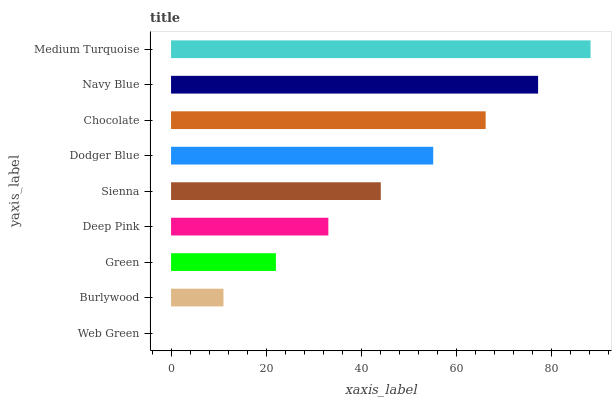Is Web Green the minimum?
Answer yes or no. Yes. Is Medium Turquoise the maximum?
Answer yes or no. Yes. Is Burlywood the minimum?
Answer yes or no. No. Is Burlywood the maximum?
Answer yes or no. No. Is Burlywood greater than Web Green?
Answer yes or no. Yes. Is Web Green less than Burlywood?
Answer yes or no. Yes. Is Web Green greater than Burlywood?
Answer yes or no. No. Is Burlywood less than Web Green?
Answer yes or no. No. Is Sienna the high median?
Answer yes or no. Yes. Is Sienna the low median?
Answer yes or no. Yes. Is Web Green the high median?
Answer yes or no. No. Is Web Green the low median?
Answer yes or no. No. 